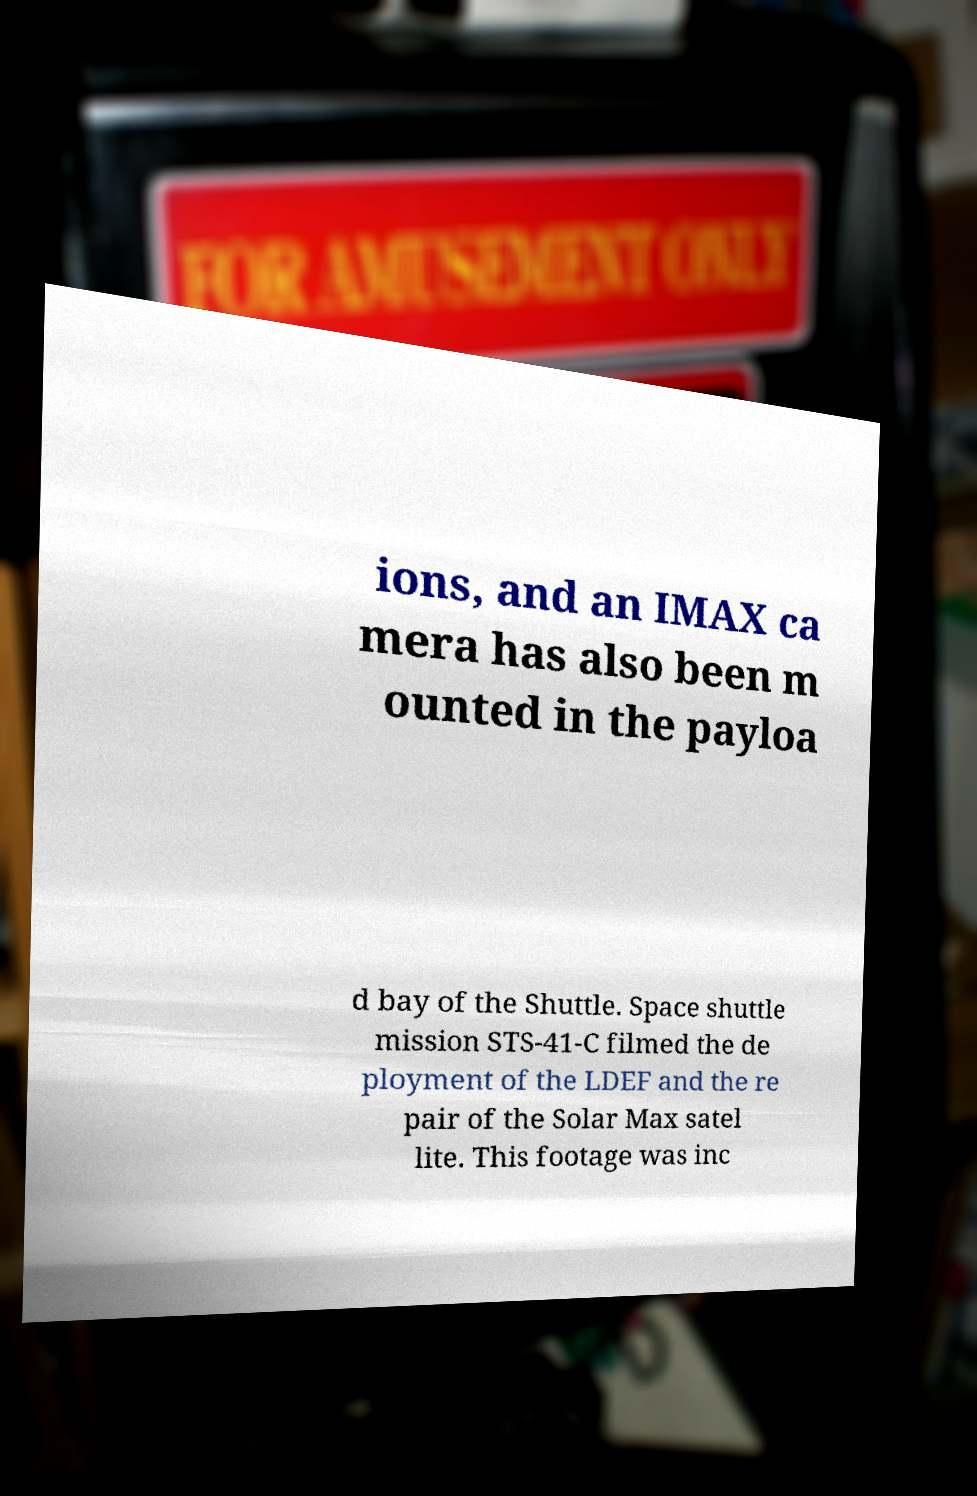Could you extract and type out the text from this image? ions, and an IMAX ca mera has also been m ounted in the payloa d bay of the Shuttle. Space shuttle mission STS-41-C filmed the de ployment of the LDEF and the re pair of the Solar Max satel lite. This footage was inc 